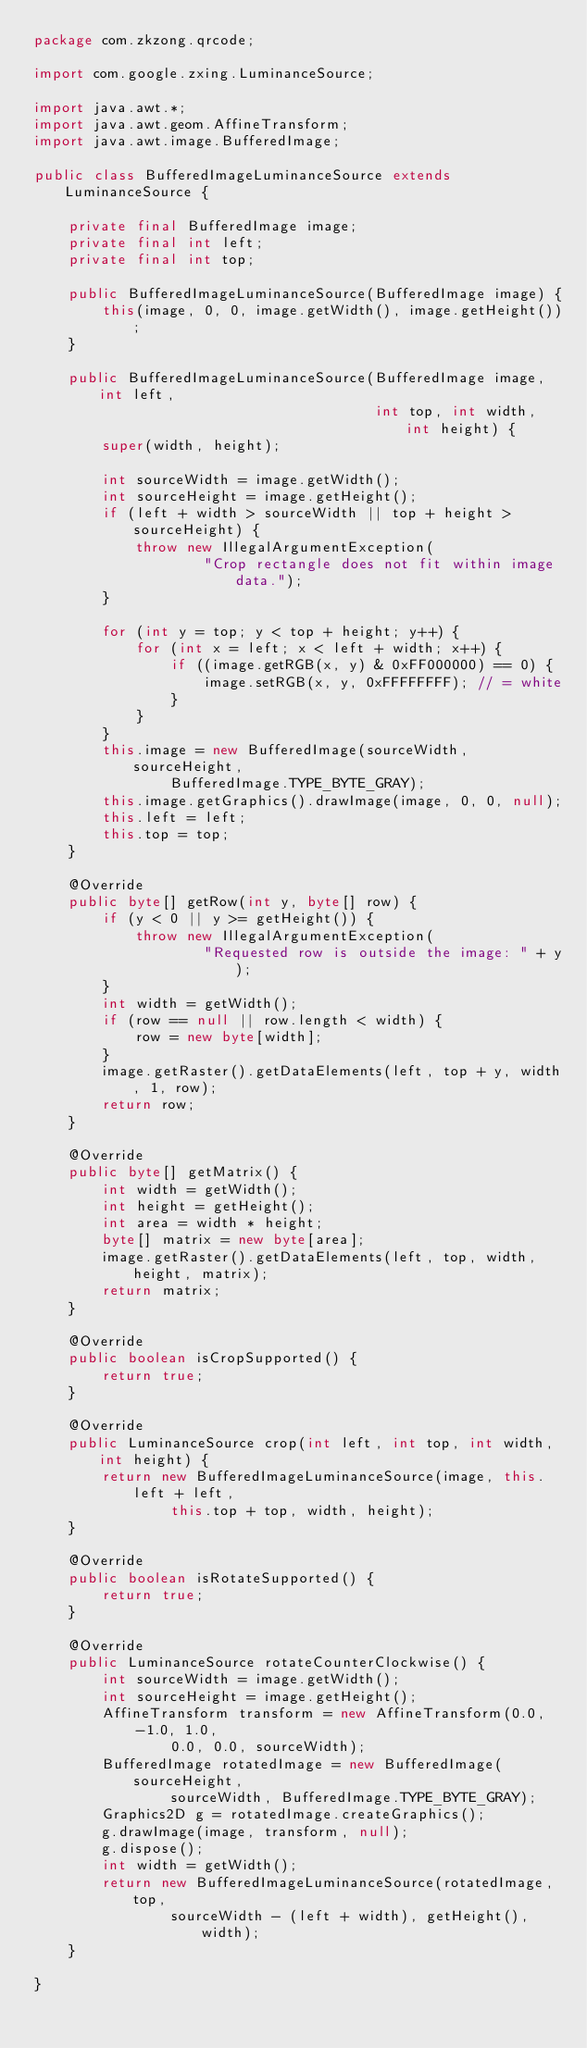<code> <loc_0><loc_0><loc_500><loc_500><_Java_>package com.zkzong.qrcode;

import com.google.zxing.LuminanceSource;

import java.awt.*;
import java.awt.geom.AffineTransform;
import java.awt.image.BufferedImage;

public class BufferedImageLuminanceSource extends LuminanceSource {

    private final BufferedImage image;
    private final int left;
    private final int top;

    public BufferedImageLuminanceSource(BufferedImage image) {
        this(image, 0, 0, image.getWidth(), image.getHeight());
    }

    public BufferedImageLuminanceSource(BufferedImage image, int left,
                                        int top, int width, int height) {
        super(width, height);

        int sourceWidth = image.getWidth();
        int sourceHeight = image.getHeight();
        if (left + width > sourceWidth || top + height > sourceHeight) {
            throw new IllegalArgumentException(
                    "Crop rectangle does not fit within image data.");
        }

        for (int y = top; y < top + height; y++) {
            for (int x = left; x < left + width; x++) {
                if ((image.getRGB(x, y) & 0xFF000000) == 0) {
                    image.setRGB(x, y, 0xFFFFFFFF); // = white
                }
            }
        }
        this.image = new BufferedImage(sourceWidth, sourceHeight,
                BufferedImage.TYPE_BYTE_GRAY);
        this.image.getGraphics().drawImage(image, 0, 0, null);
        this.left = left;
        this.top = top;
    }

    @Override
    public byte[] getRow(int y, byte[] row) {
        if (y < 0 || y >= getHeight()) {
            throw new IllegalArgumentException(
                    "Requested row is outside the image: " + y);
        }
        int width = getWidth();
        if (row == null || row.length < width) {
            row = new byte[width];
        }
        image.getRaster().getDataElements(left, top + y, width, 1, row);
        return row;
    }

    @Override
    public byte[] getMatrix() {
        int width = getWidth();
        int height = getHeight();
        int area = width * height;
        byte[] matrix = new byte[area];
        image.getRaster().getDataElements(left, top, width, height, matrix);
        return matrix;
    }

    @Override
    public boolean isCropSupported() {
        return true;
    }

    @Override
    public LuminanceSource crop(int left, int top, int width, int height) {
        return new BufferedImageLuminanceSource(image, this.left + left,
                this.top + top, width, height);
    }

    @Override
    public boolean isRotateSupported() {
        return true;
    }

    @Override
    public LuminanceSource rotateCounterClockwise() {
        int sourceWidth = image.getWidth();
        int sourceHeight = image.getHeight();
        AffineTransform transform = new AffineTransform(0.0, -1.0, 1.0,
                0.0, 0.0, sourceWidth);
        BufferedImage rotatedImage = new BufferedImage(sourceHeight,
                sourceWidth, BufferedImage.TYPE_BYTE_GRAY);
        Graphics2D g = rotatedImage.createGraphics();
        g.drawImage(image, transform, null);
        g.dispose();
        int width = getWidth();
        return new BufferedImageLuminanceSource(rotatedImage, top,
                sourceWidth - (left + width), getHeight(), width);
    }

}
</code> 